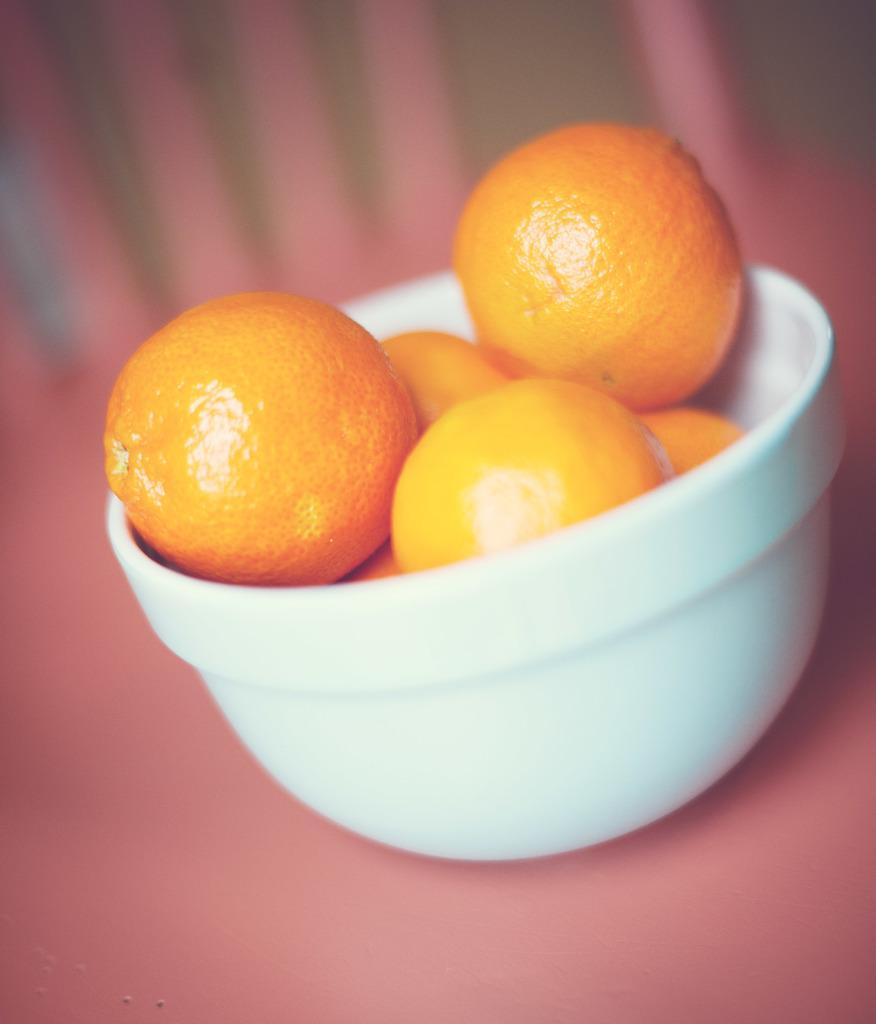Please provide a concise description of this image. In this picture I can see the pink color surface on which there is a bowl and I see oranges in it. I see that it is blurred in the background. 